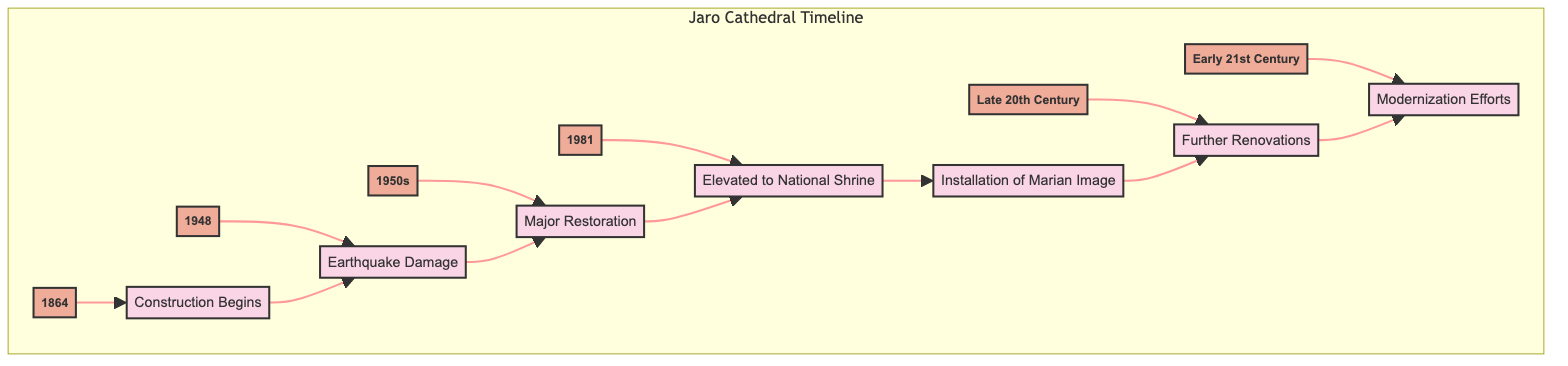What year did the construction of Jaro Cathedral begin? The diagram indicates that the construction of Jaro Cathedral began in the year 1864, as identified under the node for construction.
Answer: 1864 What major event took place in 1948? According to the diagram, the major event in 1948 was an earthquake that caused significant damage to the cathedral, leading to repairs.
Answer: Earthquake Damage How many major restoration efforts are shown in the timeline? The diagram includes one major restoration effort, which is indicated to take place throughout the 1950s as a response to earthquake damage.
Answer: One What event directly follows the installation of the Marian Image? The installation of the Marian Image is linked directly to the further renovations of the cathedral in the late 20th century, indicating that renovations come after the installation.
Answer: Further Renovations Which pope elevated the status of the cathedral in 1981? The diagram specifies that it was Pope John Paul II who elevated the cathedral's status to a National Shrine during his visit in 1981.
Answer: Pope John Paul II What was a significant outcome of the 1948 earthquake on the cathedral? The outcome noted is extensive repairs and reconstruction needed for the cathedral as a result of the earthquake in 1948.
Answer: Extensive repairs What decade saw major restoration efforts? The diagram clearly states that the major restoration efforts were conducted throughout the 1950s.
Answer: 1950s In which century did modernization efforts take place? The modernization efforts are placed in the early 21st century, according to the timeline represented in the diagram.
Answer: 21st Century What connects the earthquake damage to the major restoration? The diagram shows a direct link where the earthquake damage (1948) leads to major restoration efforts (1950s), illustrating a clear cause and effect relationship in the timeline.
Answer: Major Restoration 